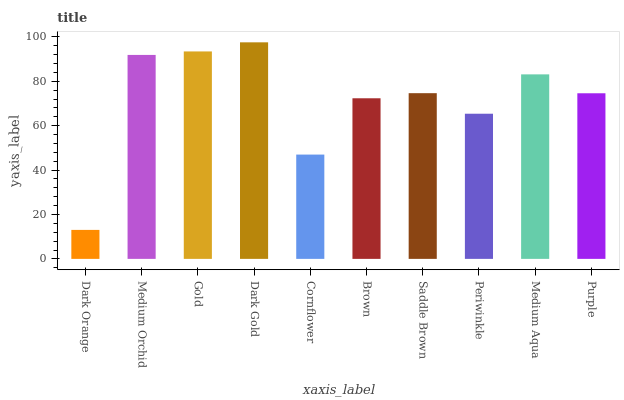Is Medium Orchid the minimum?
Answer yes or no. No. Is Medium Orchid the maximum?
Answer yes or no. No. Is Medium Orchid greater than Dark Orange?
Answer yes or no. Yes. Is Dark Orange less than Medium Orchid?
Answer yes or no. Yes. Is Dark Orange greater than Medium Orchid?
Answer yes or no. No. Is Medium Orchid less than Dark Orange?
Answer yes or no. No. Is Saddle Brown the high median?
Answer yes or no. Yes. Is Purple the low median?
Answer yes or no. Yes. Is Dark Gold the high median?
Answer yes or no. No. Is Gold the low median?
Answer yes or no. No. 